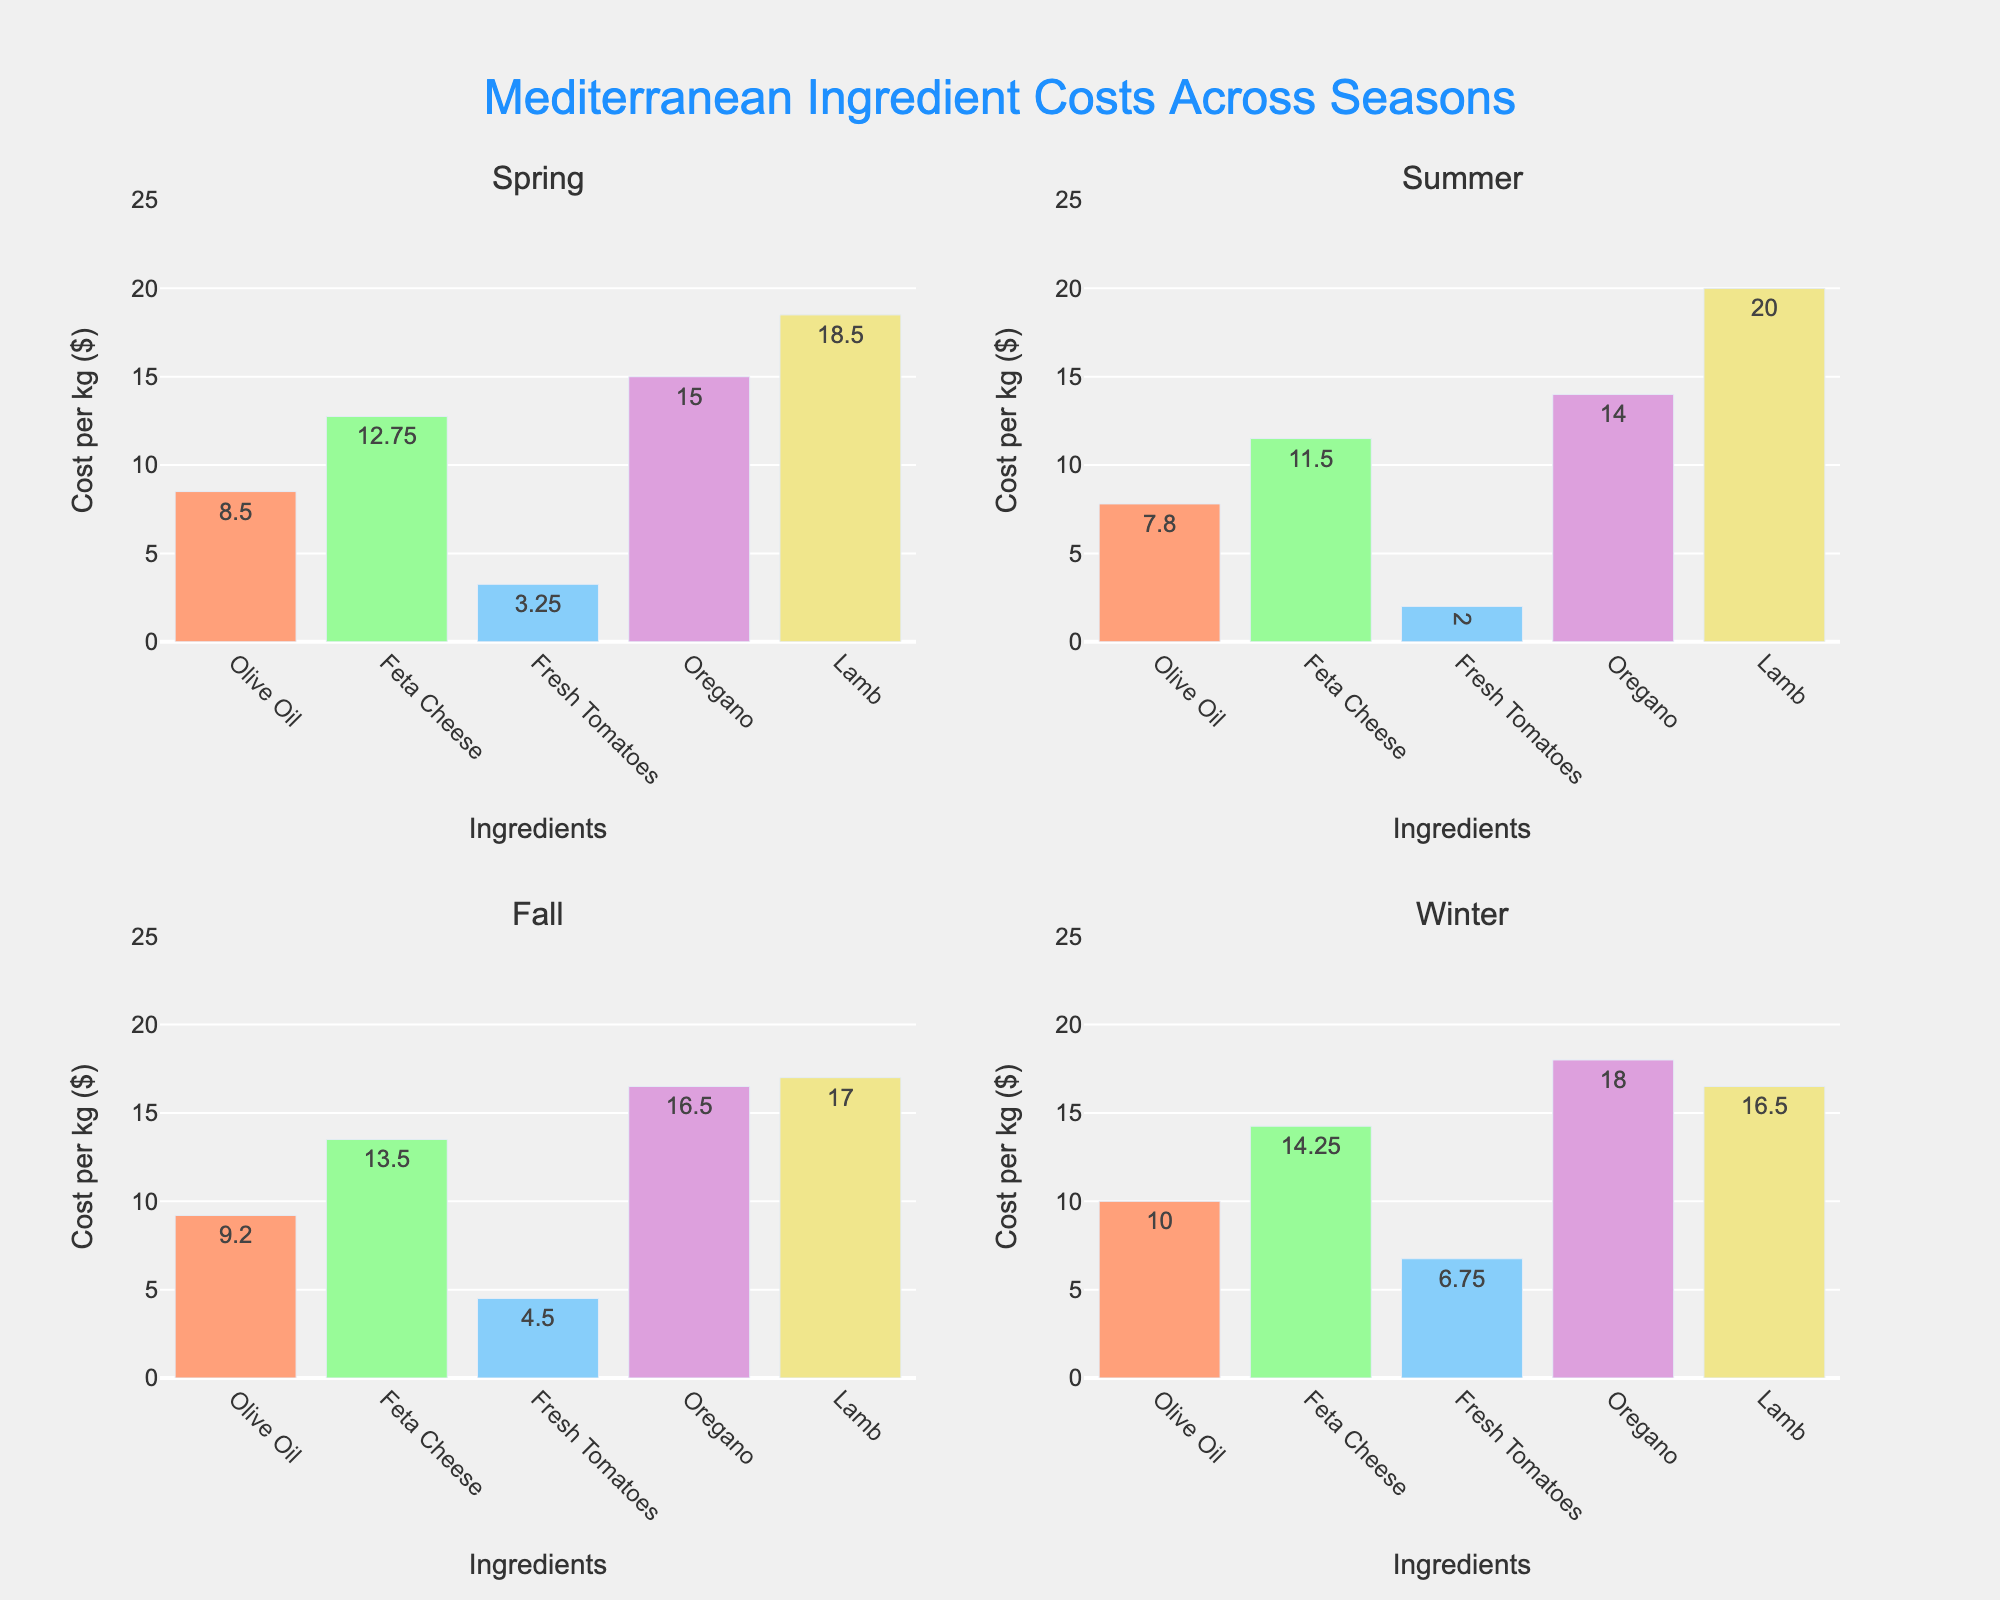which season has the highest cost for fresh tomatoes? Look at each subplot and compare the heights of the bars corresponding to fresh tomatoes. The highest bar for fresh tomatoes is in the Winter subplot with a cost of $6.75/kg.
Answer: Winter what is the total cost for all ingredients in the summer season? Sum the costs of all ingredients in the summer subplot: Olive Oil ($7.80/kg), Feta Cheese ($11.50/kg), Fresh Tomatoes ($2.00/kg), Oregano ($14.00/kg), and Lamb ($20.00/kg). The total is $7.80 + $11.50 + $2.00 + $14.00 + $20.00 = $55.30
Answer: $55.30 How does the cost of lamb in the spring compare to its cost in fall? Examine the bars for lamb in the spring and fall subplots. In spring, the cost is $18.50/kg, while in fall, it is $17.00/kg. The spring cost is $18.50 - $17.00 = $1.50 higher than in fall.
Answer: $1.50 higher What is the average cost per kg of ingredients in the winter season? Calculate the average by summing all winter ingredient costs and dividing by the number of ingredients: (Olive Oil: $10.00, Feta Cheese: $14.25, Fresh Tomatoes: $6.75, Oregano: $18.00, Lamb: $16.50). The sum is $65.50, and there are 5 ingredients. Average = $65.50 / 5 = $13.10
Answer: $13.10 Which ingredient shows the least variation in cost across all seasons? Find the ingredient with the smallest range (difference between highest and lowest costs). For instance, check Olive Oil: $10.00 (Winter) - $7.80 (Summer) = $2.20. Repeat this for all ingredients to see that Olive Oil has the least variation of $2.20.
Answer: Olive Oil How much more expensive is oregano in winter compared to summer? Compare the bars for oregano in the winter and summer subplots. In winter, the cost is $18.00/kg, and in summer, it is $14.00/kg. The difference is $18.00 - $14.00 = $4.00.
Answer: $4.00 Compare the average cost per kg of ingredients in spring with that in fall. Calculate the average cost in spring: (Olive Oil: $8.50, Feta Cheese: $12.75, Fresh Tomatoes: $3.25, Oregano: $15.00, Lamb: $18.50). The total is $58.00, and the average is $58.00/5 = $11.60. For fall: (Olive Oil: $9.20, Feta Cheese: $13.50, Fresh Tomatoes: $4.50, Oregano: $16.50, Lamb: $17.00). The total is $60.70, and the average is $60.70/5 = $12.14. Compare $11.60 (spring) with $12.14 (fall).
Answer: Spring: $11.60, Fall: $12.14 Which ingredient has the highest cost per kg in spring and what is the value? Look at the highest bar in the spring subplot. The highest cost per kg ingredient in spring is Lamb at $18.50/kg.
Answer: Lamb ($18.50/kg) What’s the difference in cost of feta cheese between summer and winter seasons? Examine the bars for feta cheese in both summer and winter subplots. In summer, the cost is $11.50/kg, and in winter, it is $14.25/kg. The difference is $14.25 - $11.50 = $2.75.
Answer: $2.75 